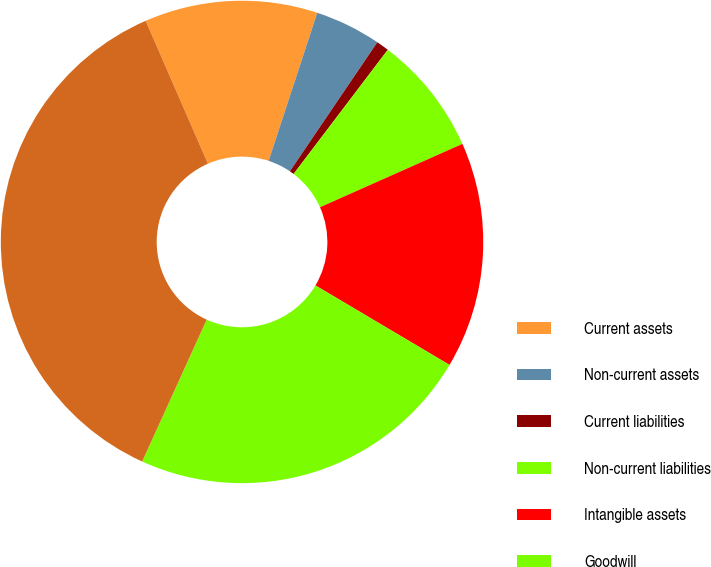Convert chart to OTSL. <chart><loc_0><loc_0><loc_500><loc_500><pie_chart><fcel>Current assets<fcel>Non-current assets<fcel>Current liabilities<fcel>Non-current liabilities<fcel>Intangible assets<fcel>Goodwill<fcel>Net assets acquired<nl><fcel>11.59%<fcel>4.43%<fcel>0.85%<fcel>8.01%<fcel>15.18%<fcel>23.28%<fcel>36.67%<nl></chart> 